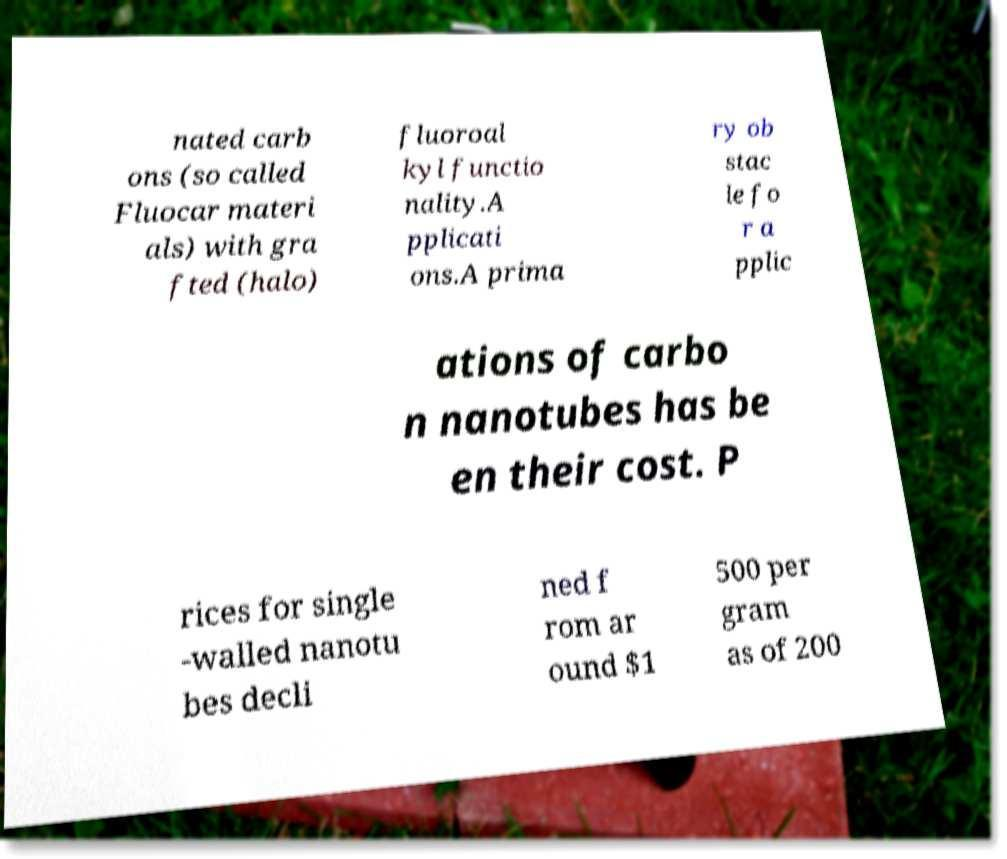Can you accurately transcribe the text from the provided image for me? nated carb ons (so called Fluocar materi als) with gra fted (halo) fluoroal kyl functio nality.A pplicati ons.A prima ry ob stac le fo r a pplic ations of carbo n nanotubes has be en their cost. P rices for single -walled nanotu bes decli ned f rom ar ound $1 500 per gram as of 200 